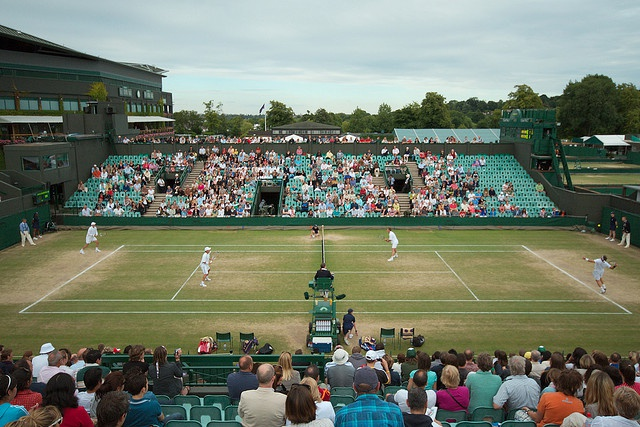Describe the objects in this image and their specific colors. I can see people in lightblue, black, gray, and darkgray tones, chair in lightblue, teal, and black tones, people in lightblue, darkgray, gray, and lightgray tones, people in lightblue, black, brown, and maroon tones, and people in lightblue, darkgray, and gray tones in this image. 